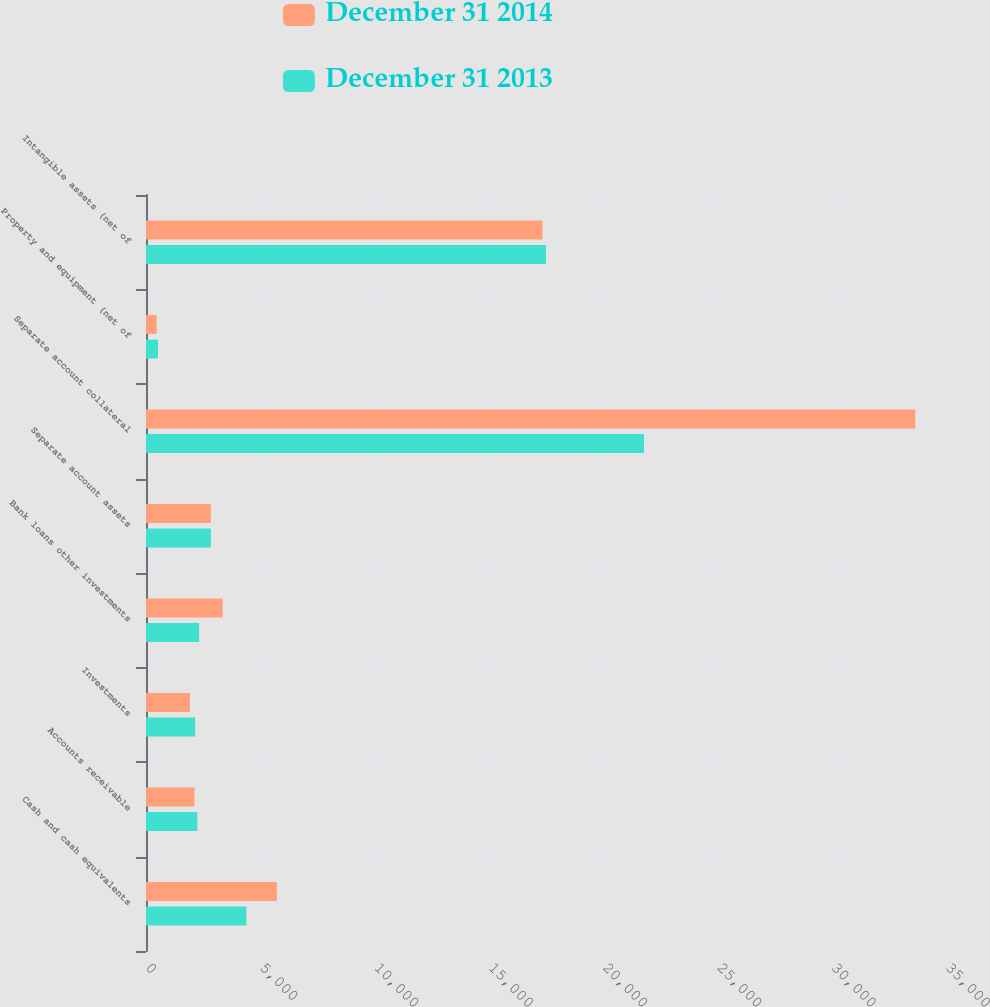Convert chart to OTSL. <chart><loc_0><loc_0><loc_500><loc_500><stacked_bar_chart><ecel><fcel>Cash and cash equivalents<fcel>Accounts receivable<fcel>Investments<fcel>Bank loans other investments<fcel>Separate account assets<fcel>Separate account collateral<fcel>Property and equipment (net of<fcel>Intangible assets (net of<nl><fcel>December 31 2014<fcel>5723<fcel>2120<fcel>1921<fcel>3352<fcel>2838.5<fcel>33654<fcel>467<fcel>17344<nl><fcel>December 31 2013<fcel>4390<fcel>2247<fcel>2151<fcel>2325<fcel>2838.5<fcel>21788<fcel>525<fcel>17501<nl></chart> 